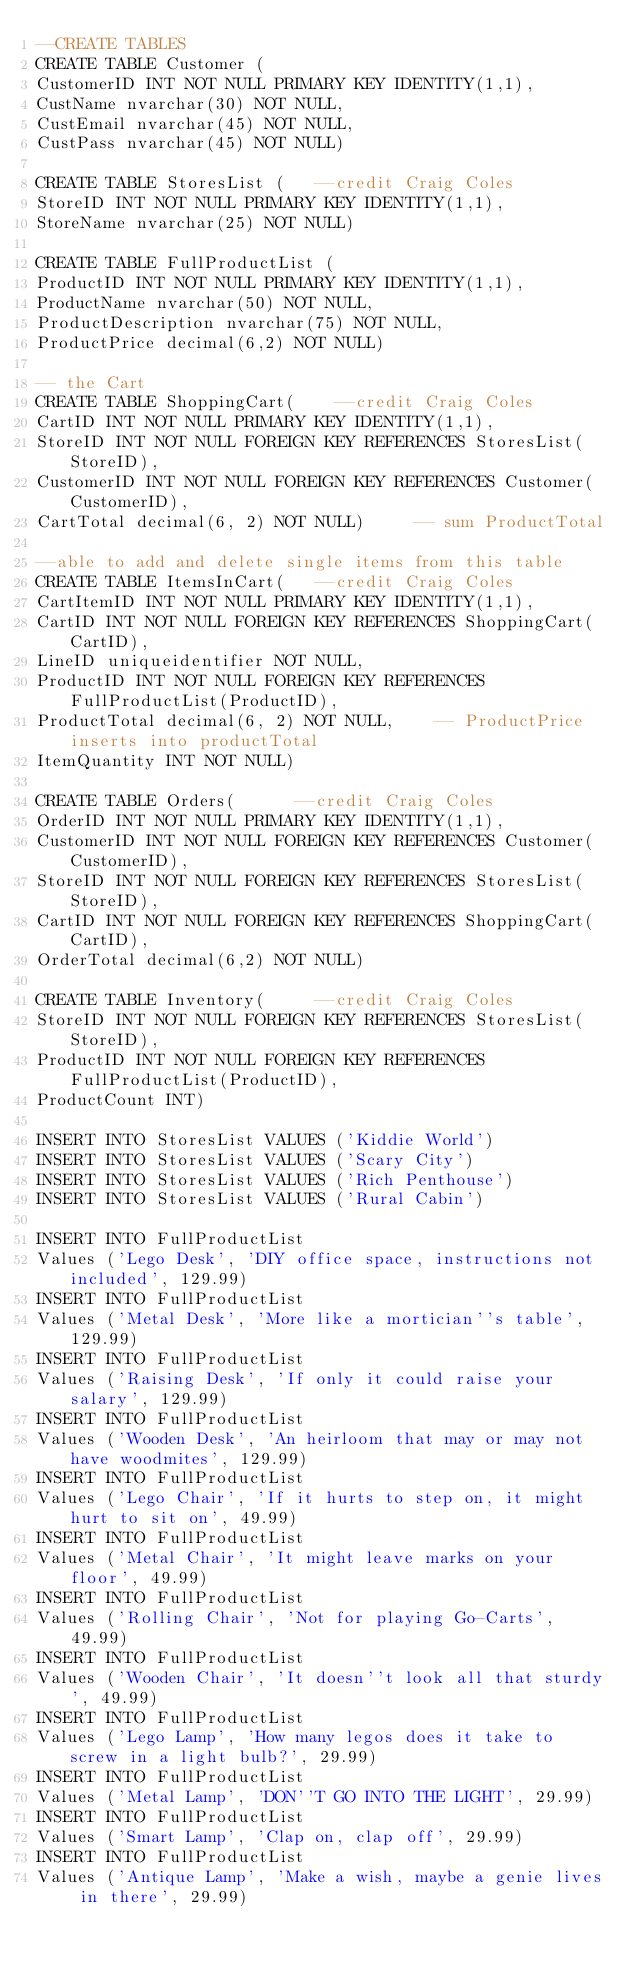<code> <loc_0><loc_0><loc_500><loc_500><_SQL_>--CREATE TABLES
CREATE TABLE Customer (
CustomerID INT NOT NULL PRIMARY KEY IDENTITY(1,1),
CustName nvarchar(30) NOT NULL, 
CustEmail nvarchar(45) NOT NULL,
CustPass nvarchar(45) NOT NULL)

CREATE TABLE StoresList (		--credit Craig Coles
StoreID INT NOT NULL PRIMARY KEY IDENTITY(1,1),
StoreName nvarchar(25) NOT NULL)

CREATE TABLE FullProductList (
ProductID INT NOT NULL PRIMARY KEY IDENTITY(1,1),
ProductName nvarchar(50) NOT NULL, 
ProductDescription nvarchar(75) NOT NULL,
ProductPrice decimal(6,2) NOT NULL)

-- the Cart
CREATE TABLE ShoppingCart(		--credit Craig Coles
CartID INT NOT NULL PRIMARY KEY IDENTITY(1,1),
StoreID INT NOT NULL FOREIGN KEY REFERENCES StoresList(StoreID),
CustomerID INT NOT NULL FOREIGN KEY REFERENCES Customer(CustomerID),
CartTotal decimal(6, 2) NOT NULL)			-- sum ProductTotal

--able to add and delete single items from this table
CREATE TABLE ItemsInCart(		--credit Craig Coles
CartItemID INT NOT NULL PRIMARY KEY IDENTITY(1,1),
CartID INT NOT NULL FOREIGN KEY REFERENCES ShoppingCart(CartID),
LineID uniqueidentifier NOT NULL,
ProductID INT NOT NULL FOREIGN KEY REFERENCES FullProductList(ProductID),
ProductTotal decimal(6, 2) NOT NULL,		-- ProductPrice inserts into productTotal
ItemQuantity INT NOT NULL)

CREATE TABLE Orders(			--credit Craig Coles
OrderID INT NOT NULL PRIMARY KEY IDENTITY(1,1),
CustomerID INT NOT NULL FOREIGN KEY REFERENCES Customer(CustomerID),
StoreID INT NOT NULL FOREIGN KEY REFERENCES StoresList(StoreID),
CartID INT NOT NULL FOREIGN KEY REFERENCES ShoppingCart(CartID),
OrderTotal decimal(6,2) NOT NULL)

CREATE TABLE Inventory(			--credit Craig Coles
StoreID INT NOT NULL FOREIGN KEY REFERENCES StoresList(StoreID),
ProductID INT NOT NULL FOREIGN KEY REFERENCES FullProductList(ProductID),
ProductCount INT)

INSERT INTO StoresList VALUES ('Kiddie World')
INSERT INTO StoresList VALUES ('Scary City')
INSERT INTO StoresList VALUES ('Rich Penthouse')
INSERT INTO StoresList VALUES ('Rural Cabin')

INSERT INTO FullProductList
Values ('Lego Desk', 'DIY office space, instructions not included', 129.99)
INSERT INTO FullProductList
Values ('Metal Desk', 'More like a mortician''s table', 129.99)
INSERT INTO FullProductList
Values ('Raising Desk', 'If only it could raise your salary', 129.99)
INSERT INTO FullProductList
Values ('Wooden Desk', 'An heirloom that may or may not have woodmites', 129.99)
INSERT INTO FullProductList
Values ('Lego Chair', 'If it hurts to step on, it might hurt to sit on', 49.99)
INSERT INTO FullProductList
Values ('Metal Chair', 'It might leave marks on your floor', 49.99)
INSERT INTO FullProductList
Values ('Rolling Chair', 'Not for playing Go-Carts', 49.99)
INSERT INTO FullProductList
Values ('Wooden Chair', 'It doesn''t look all that sturdy', 49.99)
INSERT INTO FullProductList
Values ('Lego Lamp', 'How many legos does it take to screw in a light bulb?', 29.99)
INSERT INTO FullProductList
Values ('Metal Lamp', 'DON''T GO INTO THE LIGHT', 29.99)
INSERT INTO FullProductList
Values ('Smart Lamp', 'Clap on, clap off', 29.99)
INSERT INTO FullProductList
Values ('Antique Lamp', 'Make a wish, maybe a genie lives in there', 29.99)
</code> 